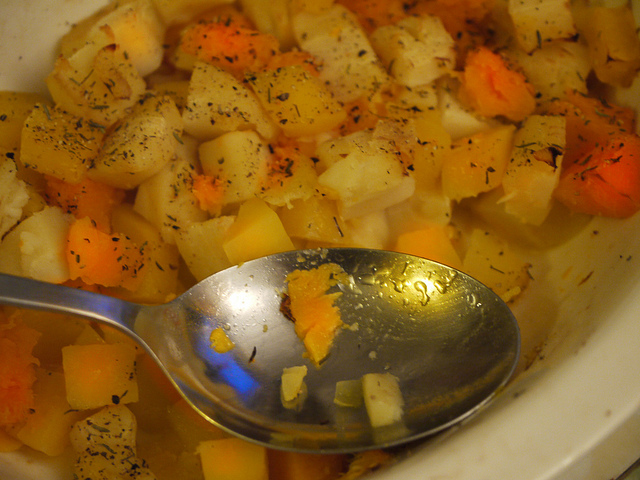<image>Did part of this meal come from a cow? I don't know if part of this meal came from a cow. There could potentially be cheese in the meal. What types of fruits are here? I don't know what types of fruits are here. It can be anything from mango, pineapples, peaches, cantaloupe, pineapple, or squash. Did part of this meal come from a cow? I am not sure if part of this meal came from a cow. However, there is cheese in the meal. What types of fruits are here? I don't know which types of fruits are here. There are no fruits visible in the image. 